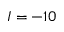Convert formula to latex. <formula><loc_0><loc_0><loc_500><loc_500>I = - 1 0</formula> 